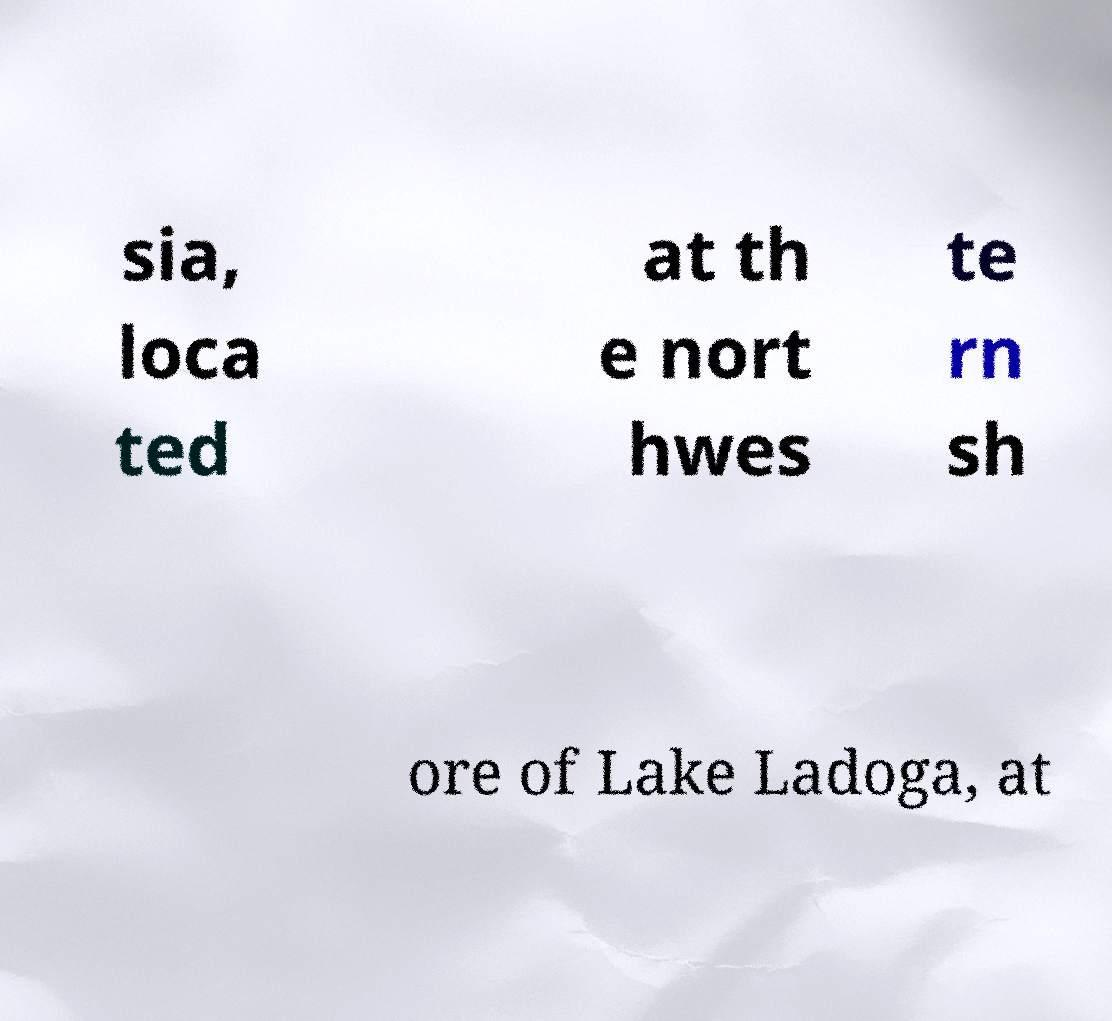Could you assist in decoding the text presented in this image and type it out clearly? sia, loca ted at th e nort hwes te rn sh ore of Lake Ladoga, at 